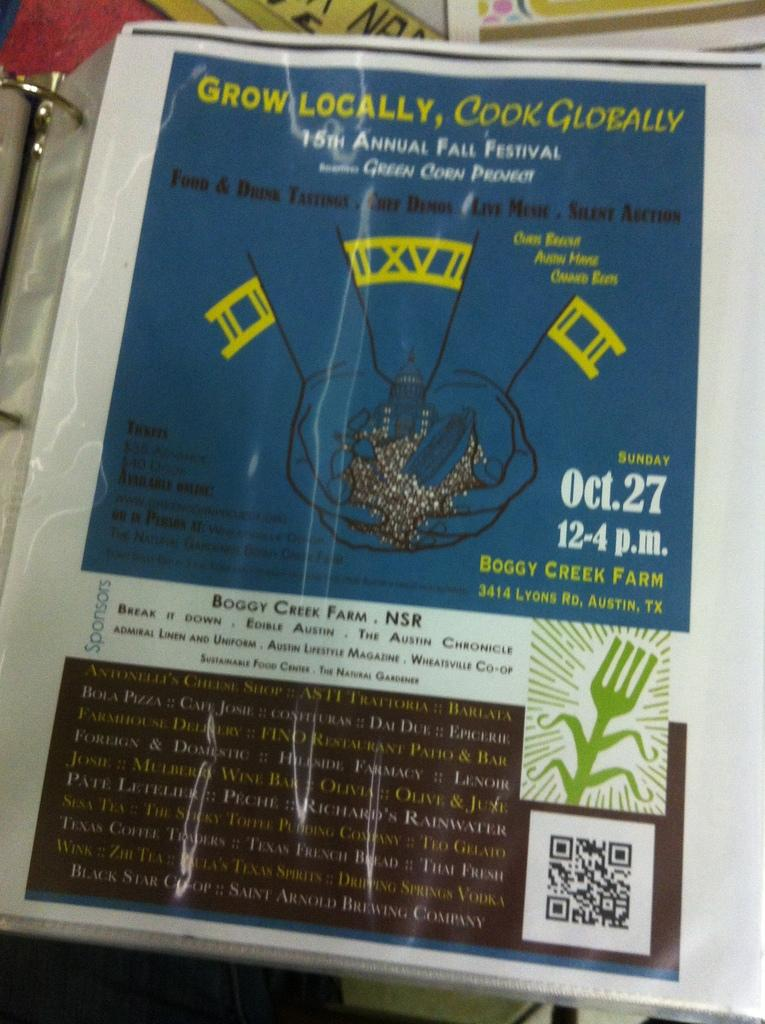<image>
Present a compact description of the photo's key features. An ad for the 15th annual Fall Festival. 